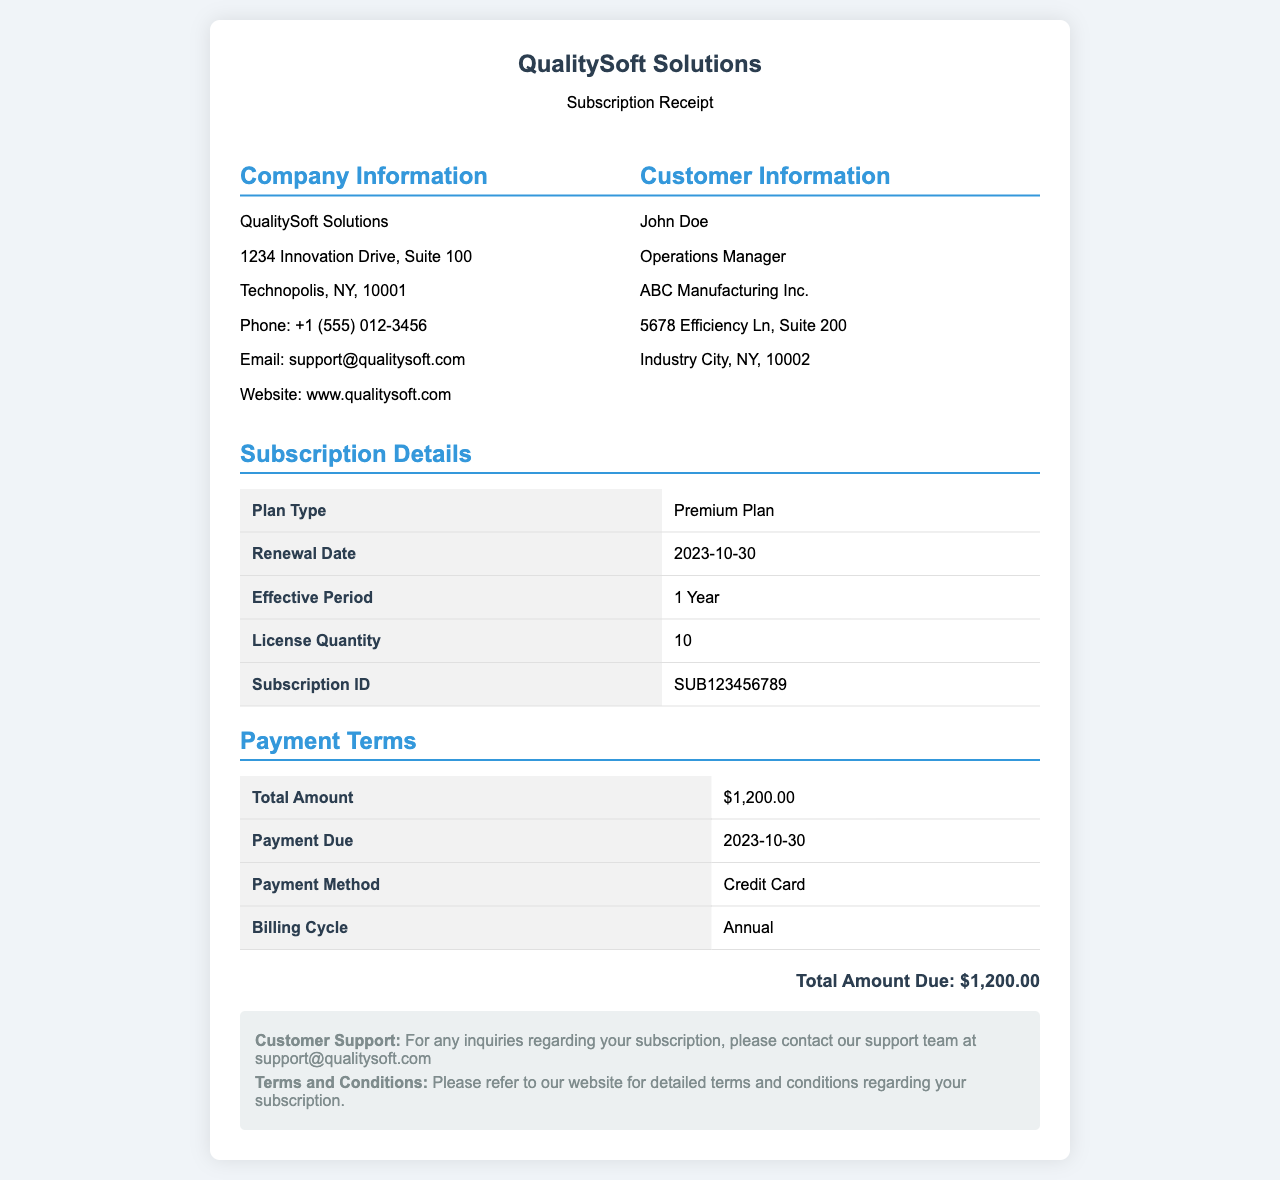What is the plan type? The plan type is specified in the subscription details section, indicating the level of service provided for the software.
Answer: Premium Plan What is the renewal date? The renewal date is the specific day when the subscription will be renewed as mentioned in the document.
Answer: 2023-10-30 How many licenses are included? The document states the number of licenses that have been purchased as part of the subscription.
Answer: 10 What is the total amount due? The total amount due is the overall payment required for the subscription renewal, as outlined in the payment terms section.
Answer: $1,200.00 What is the payment method? The payment method indicates how the total amount is to be paid, as detailed in the payment terms section.
Answer: Credit Card What is the effective period of the subscription? The effective period describes the duration for which the subscription will remain active following the renewal.
Answer: 1 Year What is the subscription ID? The subscription ID provides a unique identifier for the subscription, useful for reference or support queries.
Answer: SUB123456789 What is the billing cycle? The billing cycle describes how often payments are made for the subscription, as stated in the payment terms.
Answer: Annual When is the payment due? The payment due date indicates the specific date by which the payment must be completed for the subscription renewal.
Answer: 2023-10-30 